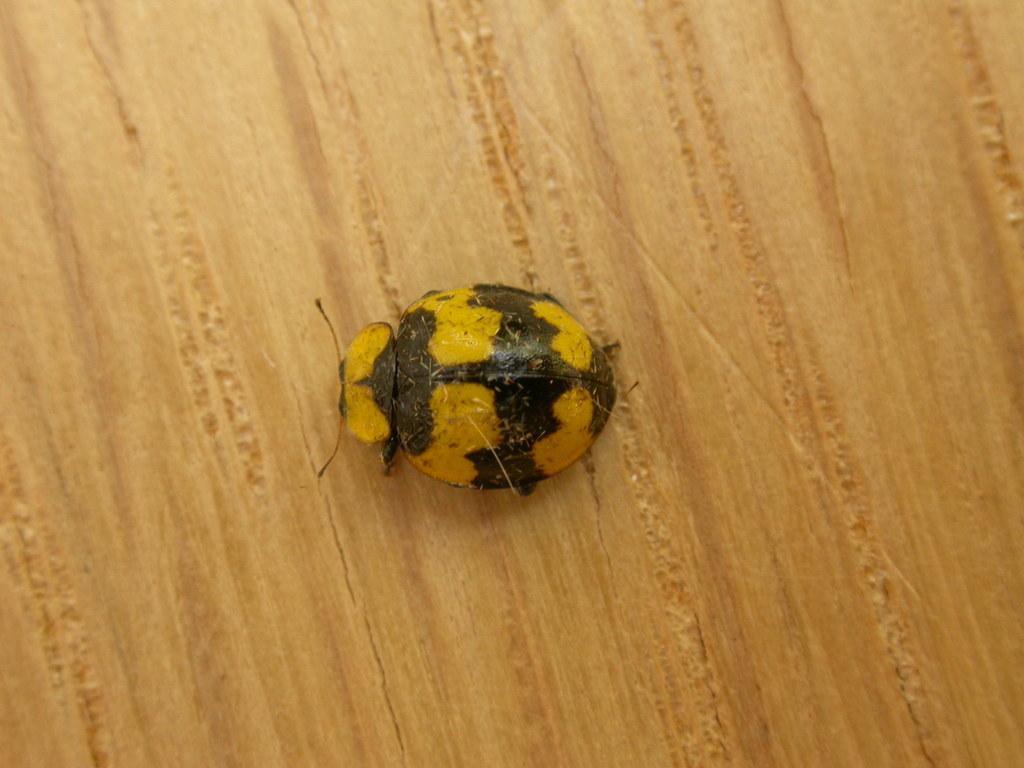Could you give a brief overview of what you see in this image? In this image there is an insect on the surface. 